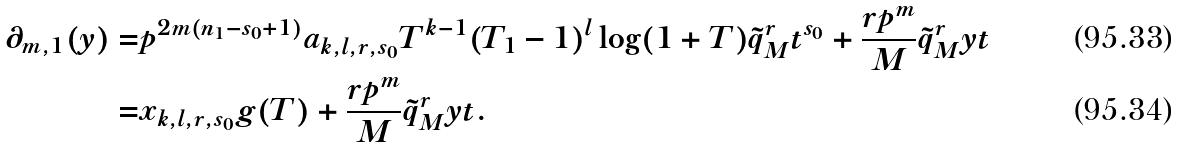<formula> <loc_0><loc_0><loc_500><loc_500>\partial _ { m , 1 } ( y ) = & p ^ { 2 m ( n _ { 1 } - s _ { 0 } + 1 ) } a _ { k , l , r , s _ { 0 } } T ^ { k - 1 } ( T _ { 1 } - 1 ) ^ { l } \log ( 1 + T ) \tilde { q } _ { M } ^ { r } t ^ { s _ { 0 } } + \frac { r p ^ { m } } { M } \tilde { q } _ { M } ^ { r } y t \\ = & x _ { k , l , r , s _ { 0 } } g ( T ) + \frac { r p ^ { m } } { M } \tilde { q } _ { M } ^ { r } y t .</formula> 